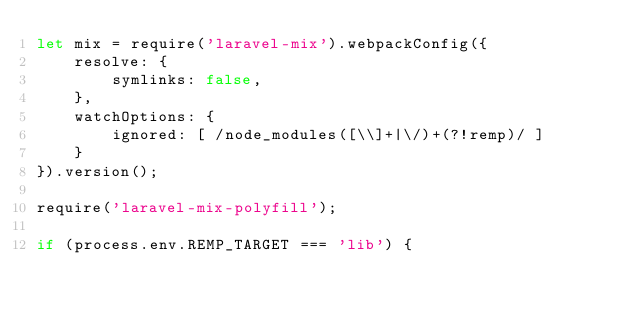<code> <loc_0><loc_0><loc_500><loc_500><_JavaScript_>let mix = require('laravel-mix').webpackConfig({
    resolve: {
        symlinks: false,
    },
    watchOptions: {
        ignored: [ /node_modules([\\]+|\/)+(?!remp)/ ]
    }
}).version();

require('laravel-mix-polyfill');

if (process.env.REMP_TARGET === 'lib') {</code> 